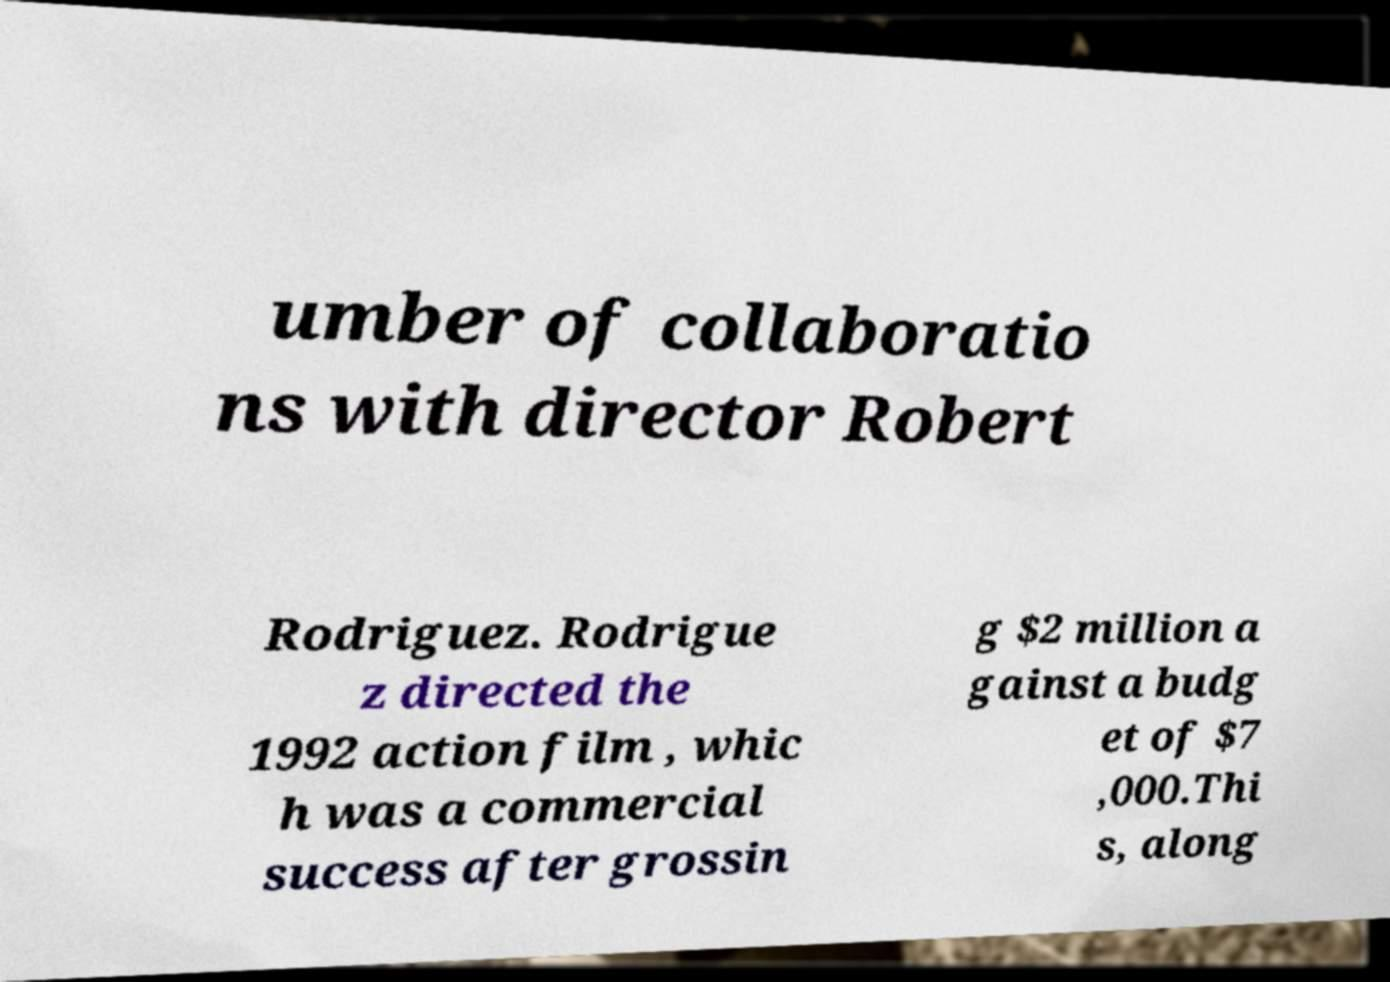Could you extract and type out the text from this image? umber of collaboratio ns with director Robert Rodriguez. Rodrigue z directed the 1992 action film , whic h was a commercial success after grossin g $2 million a gainst a budg et of $7 ,000.Thi s, along 